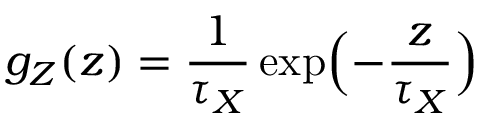<formula> <loc_0><loc_0><loc_500><loc_500>g _ { Z } ( z ) = \frac { 1 } { \tau _ { X } } \exp \left ( - \frac { z } { \tau _ { X } } \right )</formula> 